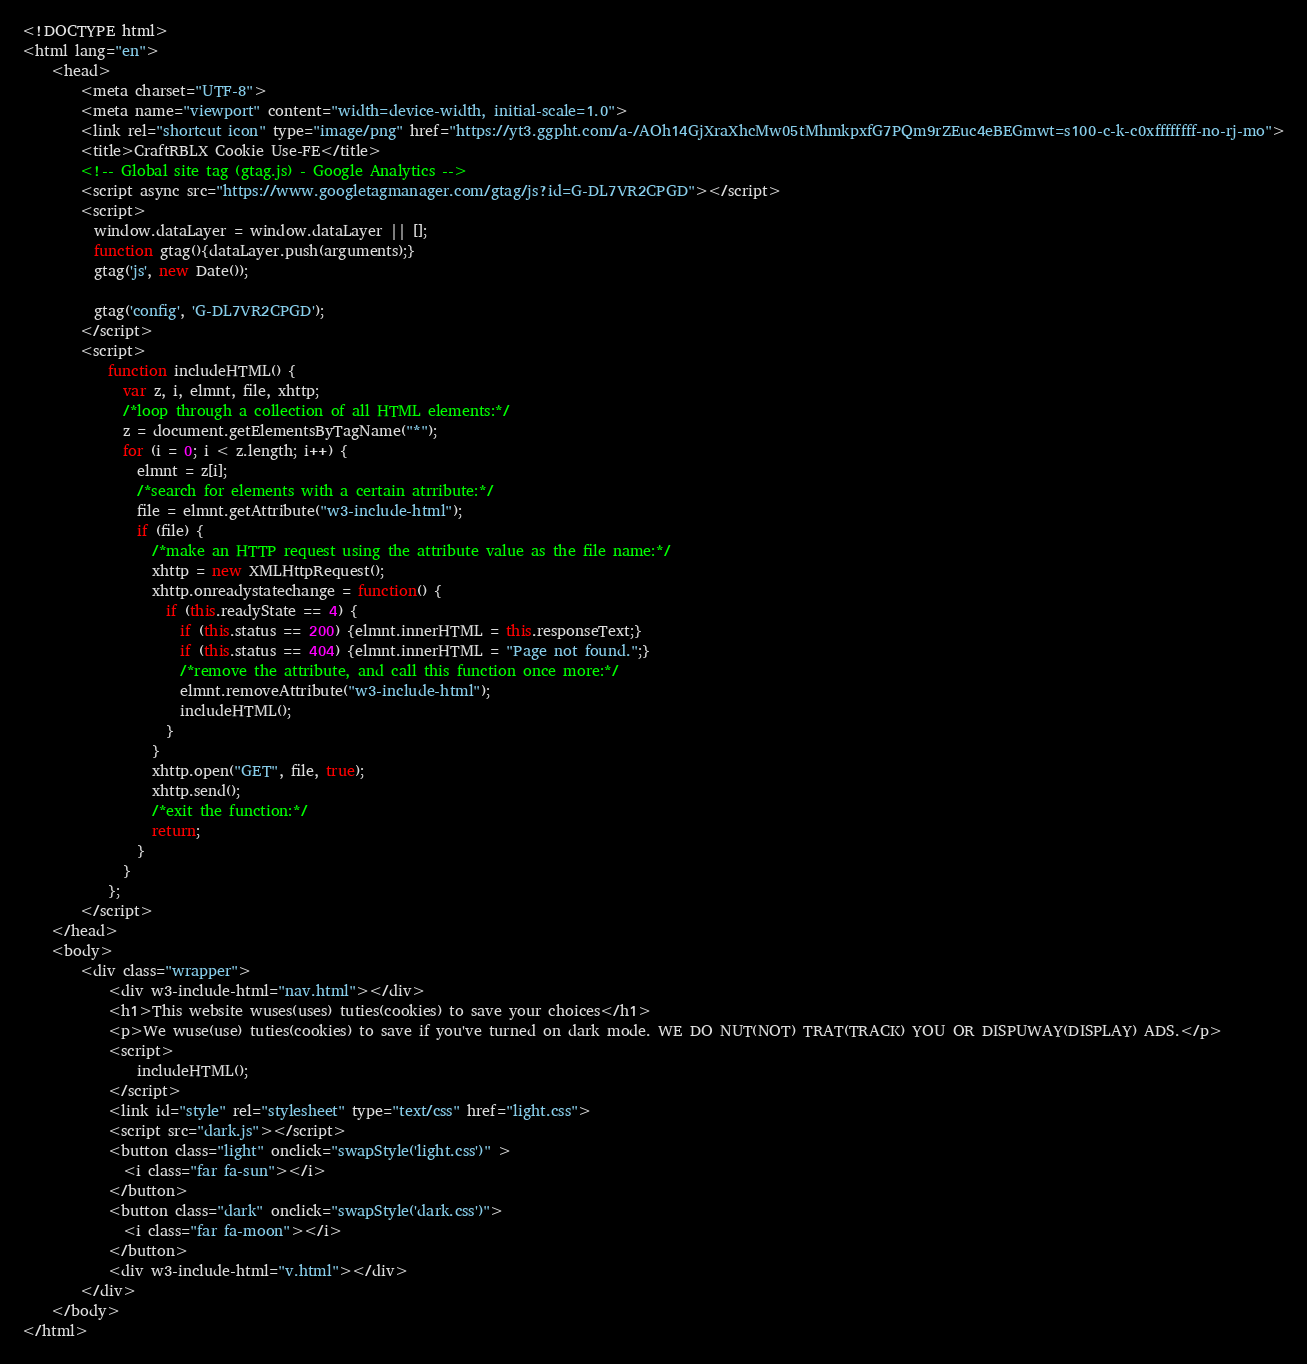<code> <loc_0><loc_0><loc_500><loc_500><_HTML_><!DOCTYPE html>
<html lang="en">
    <head>
        <meta charset="UTF-8">
        <meta name="viewport" content="width=device-width, initial-scale=1.0">
        <link rel="shortcut icon" type="image/png" href="https://yt3.ggpht.com/a-/AOh14GjXraXhcMw05tMhmkpxfG7PQm9rZEuc4eBEGmwt=s100-c-k-c0xffffffff-no-rj-mo">
        <title>CraftRBLX Cookie Use-FE</title>
        <!-- Global site tag (gtag.js) - Google Analytics -->
        <script async src="https://www.googletagmanager.com/gtag/js?id=G-DL7VR2CPGD"></script>
        <script>
          window.dataLayer = window.dataLayer || [];
          function gtag(){dataLayer.push(arguments);}
          gtag('js', new Date());

          gtag('config', 'G-DL7VR2CPGD');
        </script>
        <script>
            function includeHTML() {
              var z, i, elmnt, file, xhttp;
              /*loop through a collection of all HTML elements:*/
              z = document.getElementsByTagName("*");
              for (i = 0; i < z.length; i++) {
                elmnt = z[i];
                /*search for elements with a certain atrribute:*/
                file = elmnt.getAttribute("w3-include-html");
                if (file) {
                  /*make an HTTP request using the attribute value as the file name:*/
                  xhttp = new XMLHttpRequest();
                  xhttp.onreadystatechange = function() {
                    if (this.readyState == 4) {
                      if (this.status == 200) {elmnt.innerHTML = this.responseText;}
                      if (this.status == 404) {elmnt.innerHTML = "Page not found.";}
                      /*remove the attribute, and call this function once more:*/
                      elmnt.removeAttribute("w3-include-html");
                      includeHTML();
                    }
                  }      
                  xhttp.open("GET", file, true);
                  xhttp.send();
                  /*exit the function:*/
                  return;
                }
              }
            };
        </script>
    </head>
    <body>
        <div class="wrapper">
            <div w3-include-html="nav.html"></div>
            <h1>This website wuses(uses) tuties(cookies) to save your choices</h1>
            <p>We wuse(use) tuties(cookies) to save if you've turned on dark mode. WE DO NUT(NOT) TRAT(TRACK) YOU OR DISPUWAY(DISPLAY) ADS.</p>
            <script>
                includeHTML();
            </script>
            <link id="style" rel="stylesheet" type="text/css" href="light.css">
            <script src="dark.js"></script>
            <button class="light" onclick="swapStyle('light.css')" >
              <i class="far fa-sun"></i>      
            </button>
            <button class="dark" onclick="swapStyle('dark.css')">
              <i class="far fa-moon"></i>
            </button>
            <div w3-include-html="v.html"></div>
        </div>
    </body>
</html>
</code> 